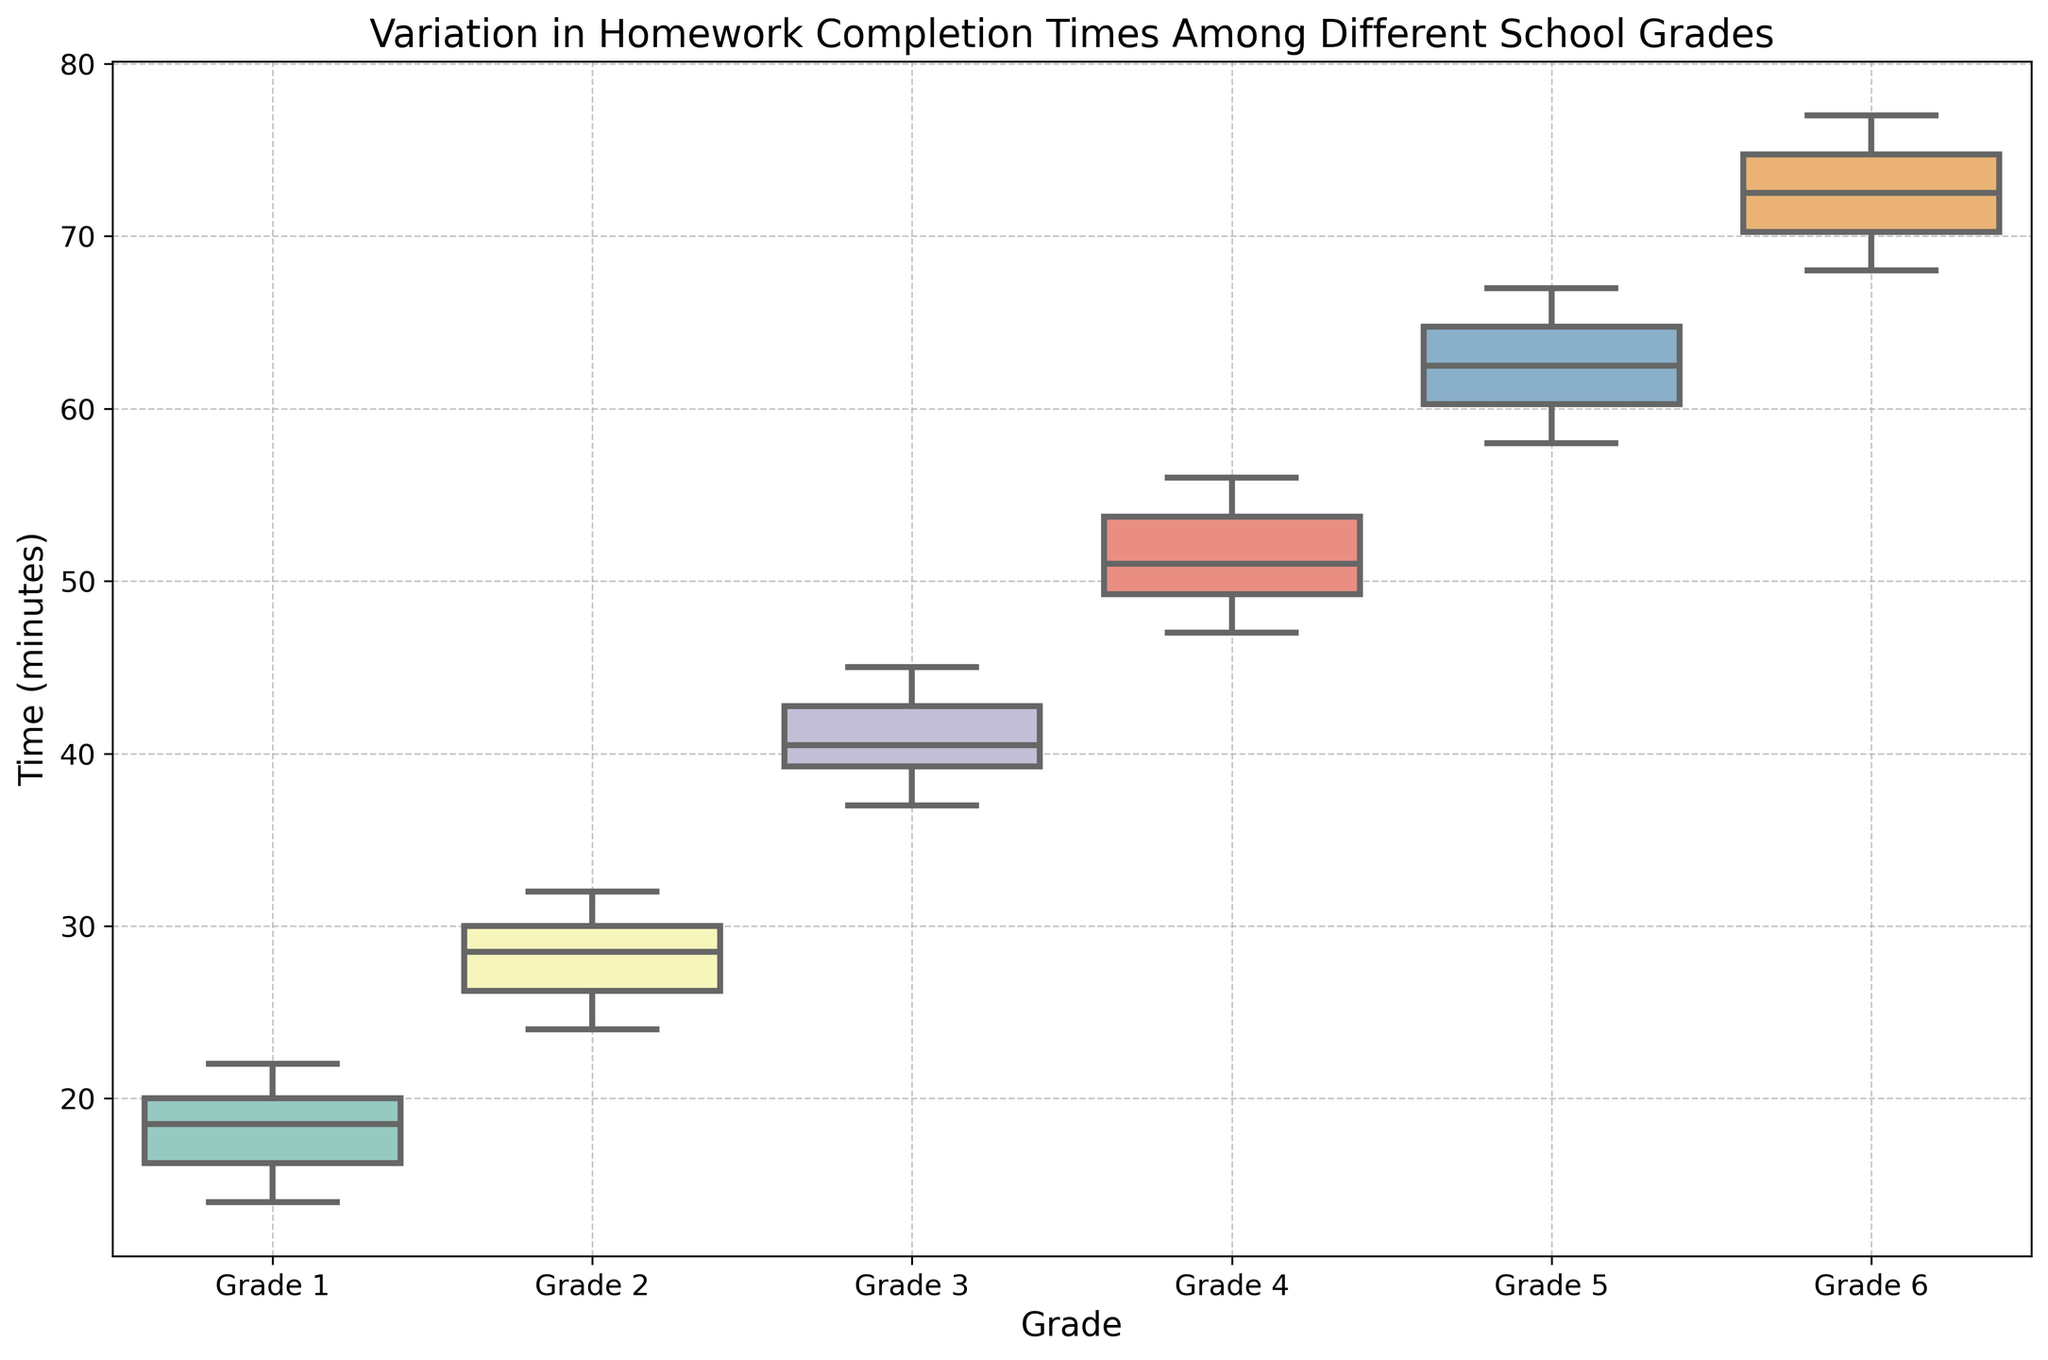What is the median homework completion time for Grade 1? The median completion time is the middle value when the times for Grade 1 are ordered. Sorting the times (14, 15, 16, 17, 18, 19, 20, 20, 21, 22), the median is (18+19)/2 as there are 10 data points.
Answer: 18.5 Which grade has the highest variability in homework completion times based on the interquartile range (IQR)? The grade with the widest box in the box plot corresponds to the highest IQR (difference between the third quartile Q3 and the first quartile Q1). By visual inspection, Grade 5 has the widest box.
Answer: Grade 5 Which grade has the smallest range of homework completion times? The range is the difference between the maximum and minimum values for each grade. Grade 1 has the smallest range visually since the whiskers and outliers are shorter compared to others.
Answer: Grade 1 What is the median homework completion time for Grade 6? Locate Grade 6 in the box plot and find the middle line inside the box, representing the median completion time.
Answer: 72 Which grade has the highest median homework completion time? Compare the central lines inside the boxes for each grade, and Grade 6’s median line is the highest.
Answer: Grade 6 How does the median homework completion time for Grade 3 compare to Grade 4? Find the median lines in the boxes for both Grade 3 and Grade 4 and compare their positions. Grade 4’s median is higher than Grade 3’s.
Answer: Grade 4 has a higher median What is the interquartile range (IQR) for Grade 3? IQR is calculated as Q3 (upper quartile) minus Q1 (lower quartile). Locate Q3 and Q1 in the box for Grade 3 and calculate the difference.
Answer: 6 (43 - 37) Does any grade have outliers in the homework completion times? If so, which one(s)? Look for points that lie outside the whiskers of the box plots for each grade. None of the grades display outliers visually in this box plot.
Answer: No Is the range of completion times for Grade 2 greater or less than that for Grade 5? Compare the length of the whiskers for Grade 2 and Grade 5. Grade 5 has a longer whisker range.
Answer: Greater for Grade 5 Comparing Grade 4 and Grade 5, which one has a higher upper quartile (Q3)? Identify Q3 (the top boundary of the box) for Grade 4 and Grade 5 and compare their heights. Grade 5’s Q3 is higher.
Answer: Grade 5 